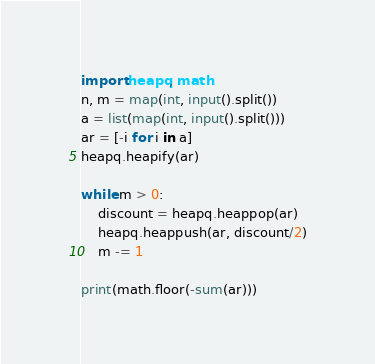Convert code to text. <code><loc_0><loc_0><loc_500><loc_500><_Python_>import heapq, math
n, m = map(int, input().split())
a = list(map(int, input().split()))
ar = [-i for i in a]
heapq.heapify(ar)

while m > 0:
    discount = heapq.heappop(ar)
    heapq.heappush(ar, discount/2)
    m -= 1

print(math.floor(-sum(ar)))
</code> 